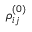<formula> <loc_0><loc_0><loc_500><loc_500>\rho _ { i j } ^ { ( 0 ) }</formula> 